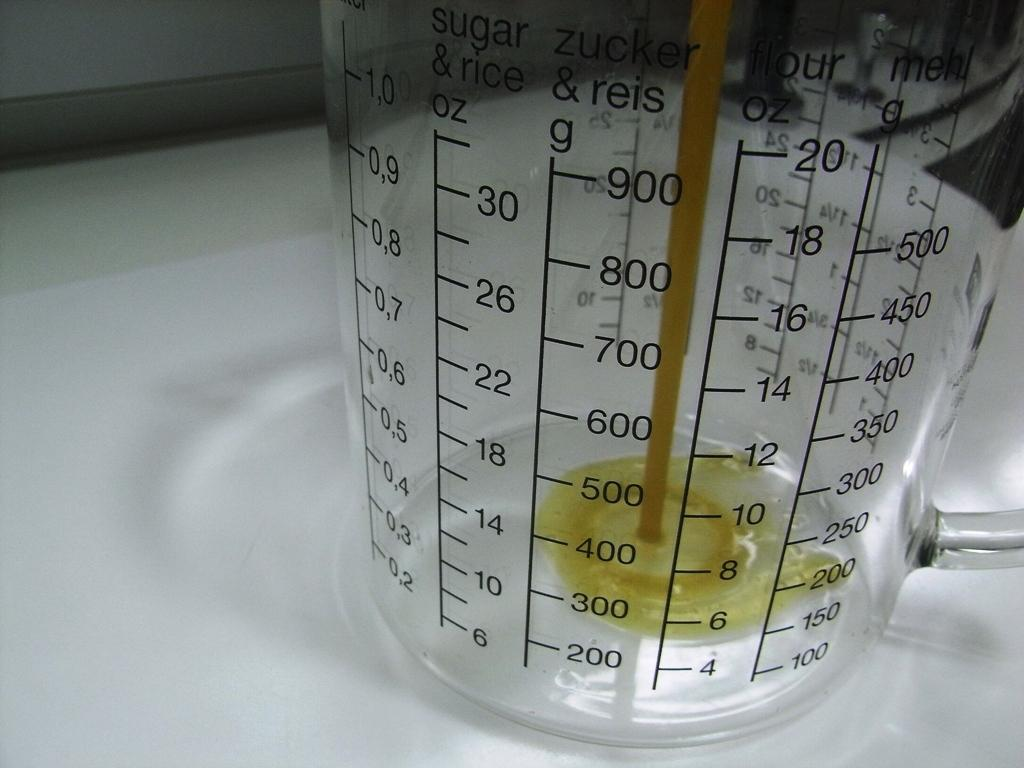<image>
Offer a succinct explanation of the picture presented. yellow liquid pouring into measuring that is labeled for oz and g for sugar and rice 